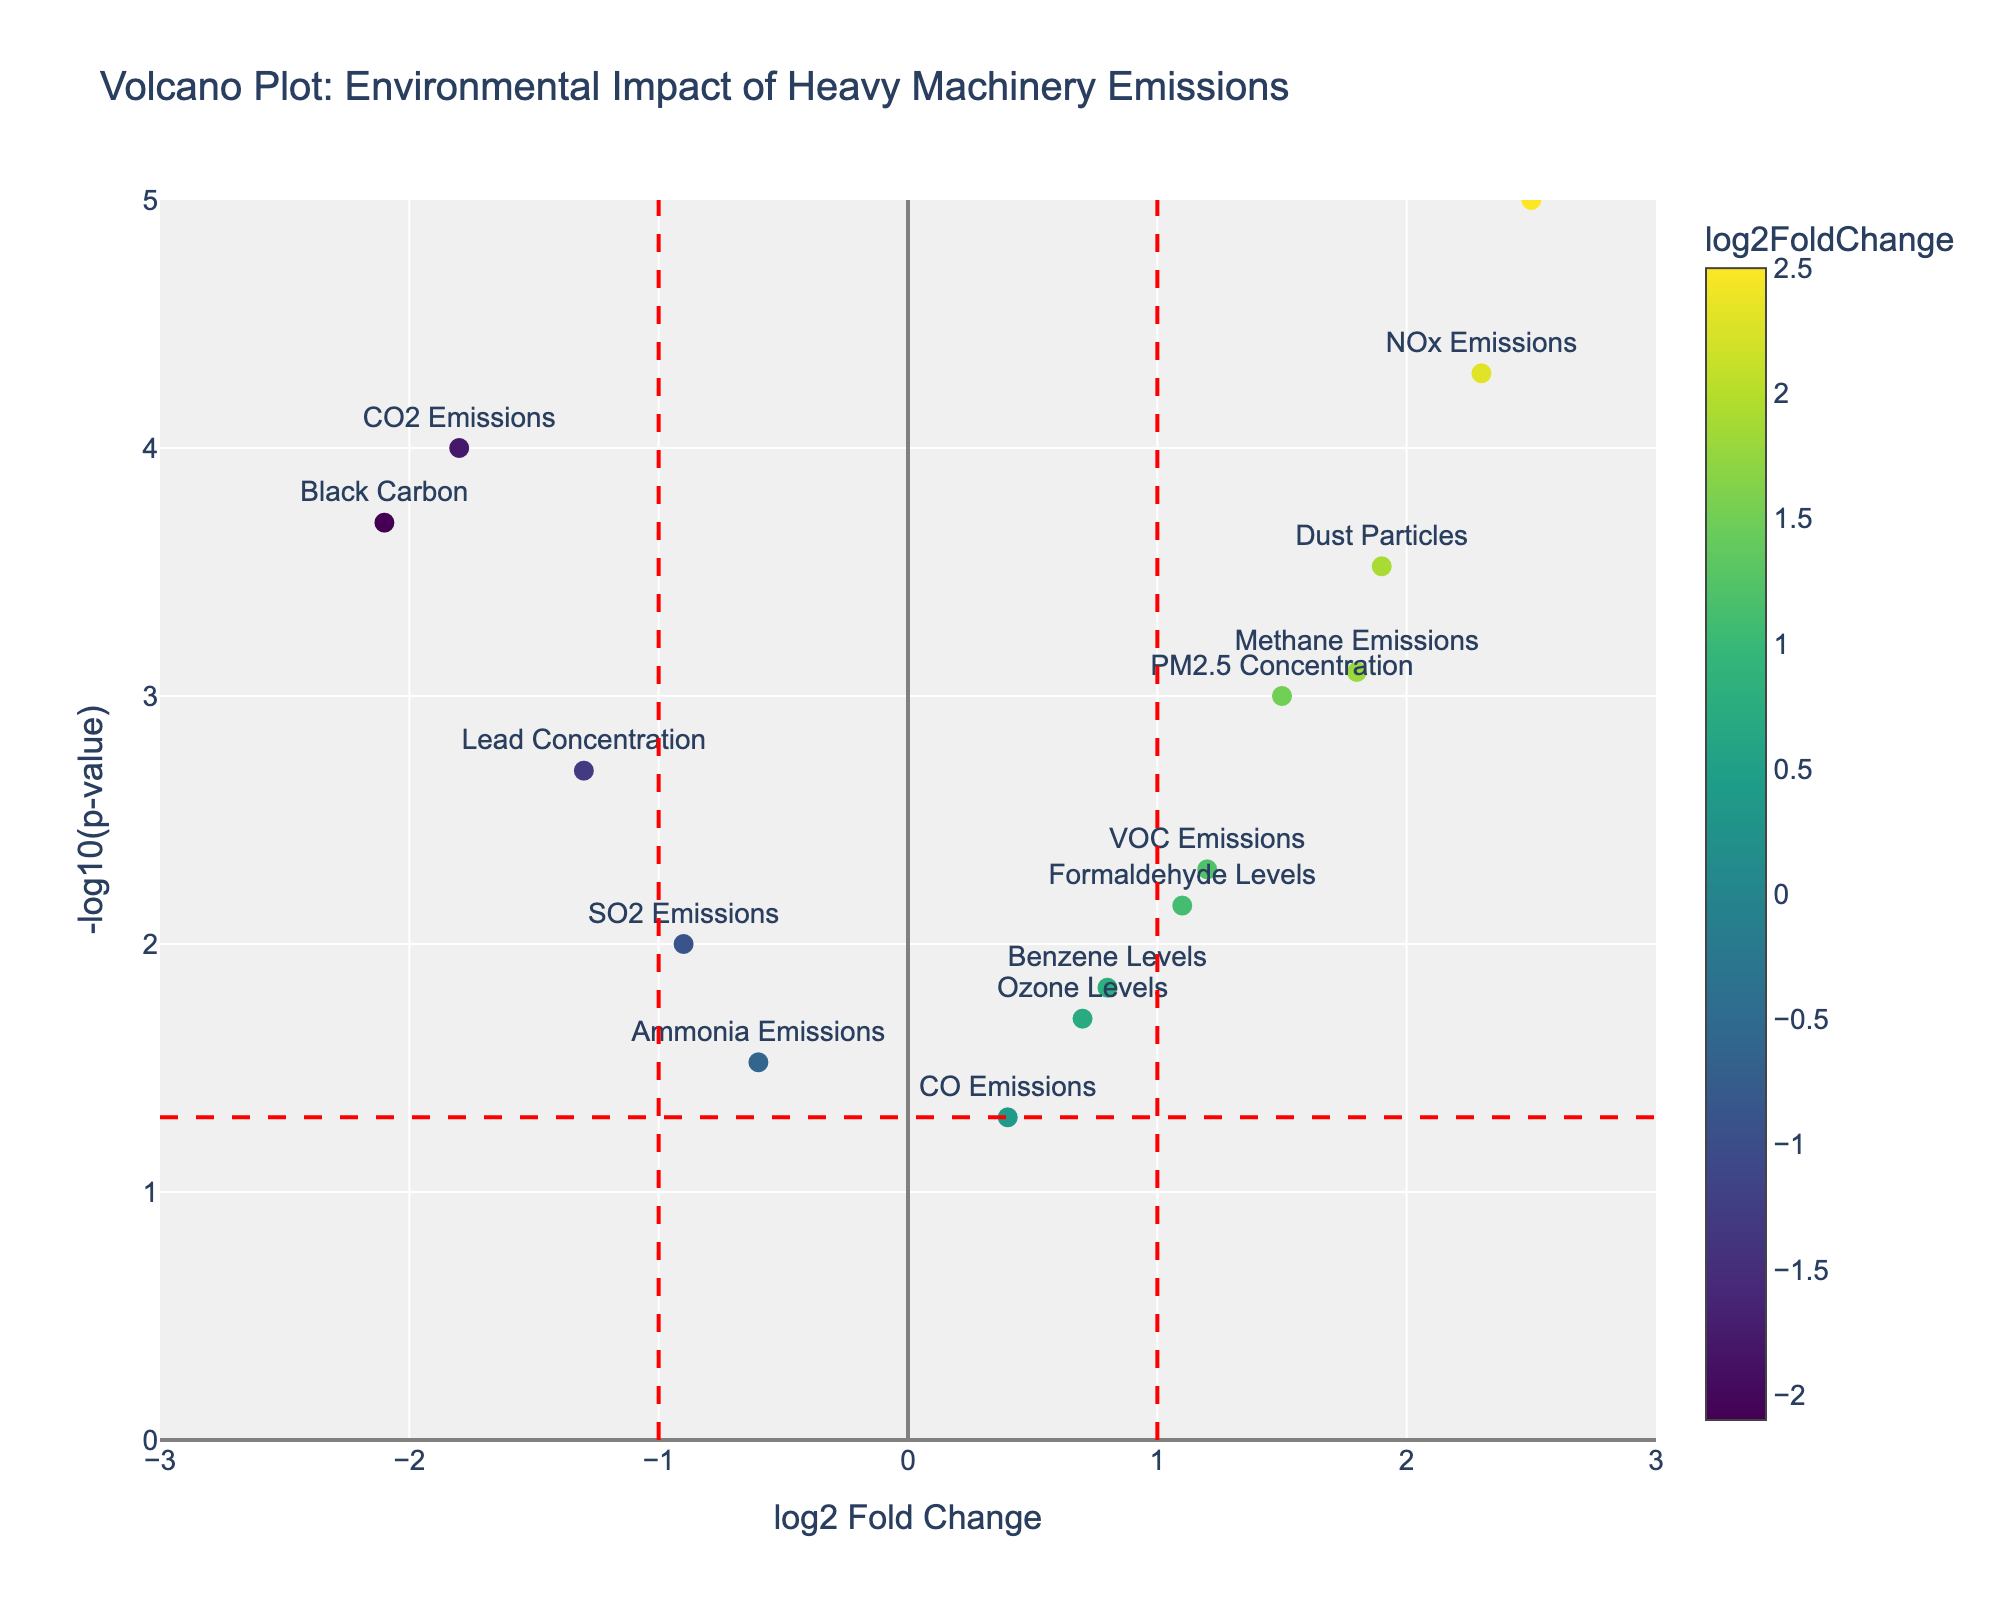What is the title of the plot? The title of the plot is explicitly shown at the top of the plot.
Answer: Volcano Plot: Environmental Impact of Heavy Machinery Emissions How many data points are displayed in the plot? Each marker on the plot represents a data point. By counting the markers, we find there are 15.
Answer: 15 Which data point has the highest log2 fold change? By examining the x-axis, we can see "Noise Pollution" is positioned furthest to the right, indicating it has the highest log2 fold change.
Answer: Noise Pollution Which data point has the lowest p-value? The y-axis represents -log10(p-value). The higher the point on the y-axis, the lower the p-value. "Noise Pollution" is the highest point, indicating the lowest p-value.
Answer: Noise Pollution What does the color of each marker on the plot indicate? The color scale shown next to the plot indicates that it represents the log2 fold change value. Darker colors indicate larger values.
Answer: log2 fold change Which data points have a log2 fold change less than -1? By looking left of the vertical red dashed line at x=-1, the points are "CO2 Emissions," "Black Carbon," and "Lead Concentration."
Answer: CO2 Emissions, Black Carbon, Lead Concentration Which data points have a significant p-value and a positive log2 fold change? Points above the horizontal dashed line and to the right of the vertical line at x=0 have significant p-values and positive fold changes. These include "NOx Emissions," "PM2.5 Concentration," "VOC Emissions," "Noise Pollution," "Methane Emissions," "Dust Particles," "Ozone Levels," "Formaldehyde Levels," and "Benzene Levels."
Answer: NOx Emissions, PM2.5 Concentration, VOC Emissions, Noise Pollution, Methane Emissions, Dust Particles, Ozone Levels, Formaldehyde Levels, Benzene Levels What is the log2 fold change and p-value for Methane Emissions? Hovering over the point or looking at the position on the x and y axes (considering the scale), we get log2 fold change of 1.8 and a p-value of 0.0008.
Answer: log2FC: 1.8, p-value: 0.0008 Are there any data points with a log2 fold change exactly equal to 0? By examining the x-axis at the position x=0, no points are plotted directly on this line, meaning there are no data points with a log2 fold change of 0.
Answer: No What is the range of the x-axis and y-axis? The x-axis ranges from -3 to 3, and the y-axis ranges from 0 to 5, as indicated by the plot.
Answer: x-axis: -3 to 3, y-axis: 0 to 5 